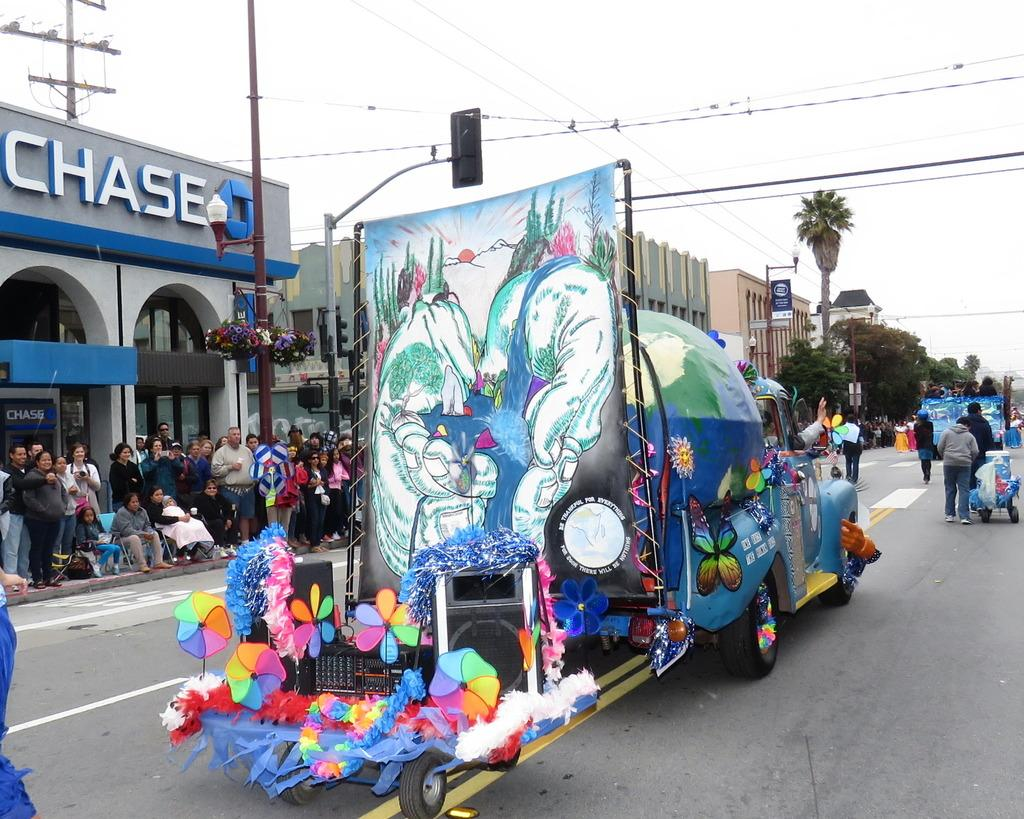Provide a one-sentence caption for the provided image. A colorfull float alongside a building that says Chase on it. 